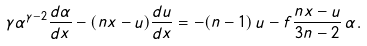<formula> <loc_0><loc_0><loc_500><loc_500>\gamma \alpha ^ { \gamma - 2 } \frac { d \alpha } { d x } - ( n x - u ) \frac { d u } { d x } = - ( n - 1 ) \, u - f \frac { n x - u } { 3 n - 2 } \, \alpha .</formula> 